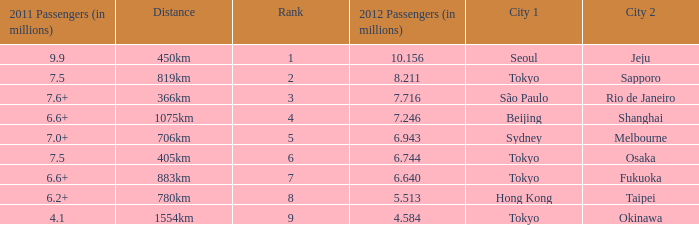Which city is listed first when Okinawa is listed as the second city? Tokyo. 